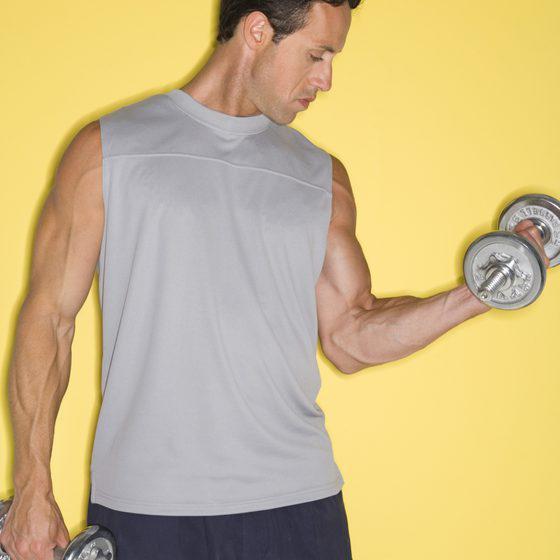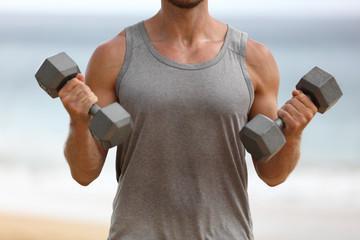The first image is the image on the left, the second image is the image on the right. Analyze the images presented: Is the assertion "At least one athlete performing a dumbbell workout is a blonde woman in a purple tanktop." valid? Answer yes or no. No. The first image is the image on the left, the second image is the image on the right. Given the left and right images, does the statement "The person in the image on the left is lifting a single weight with one hand." hold true? Answer yes or no. Yes. 